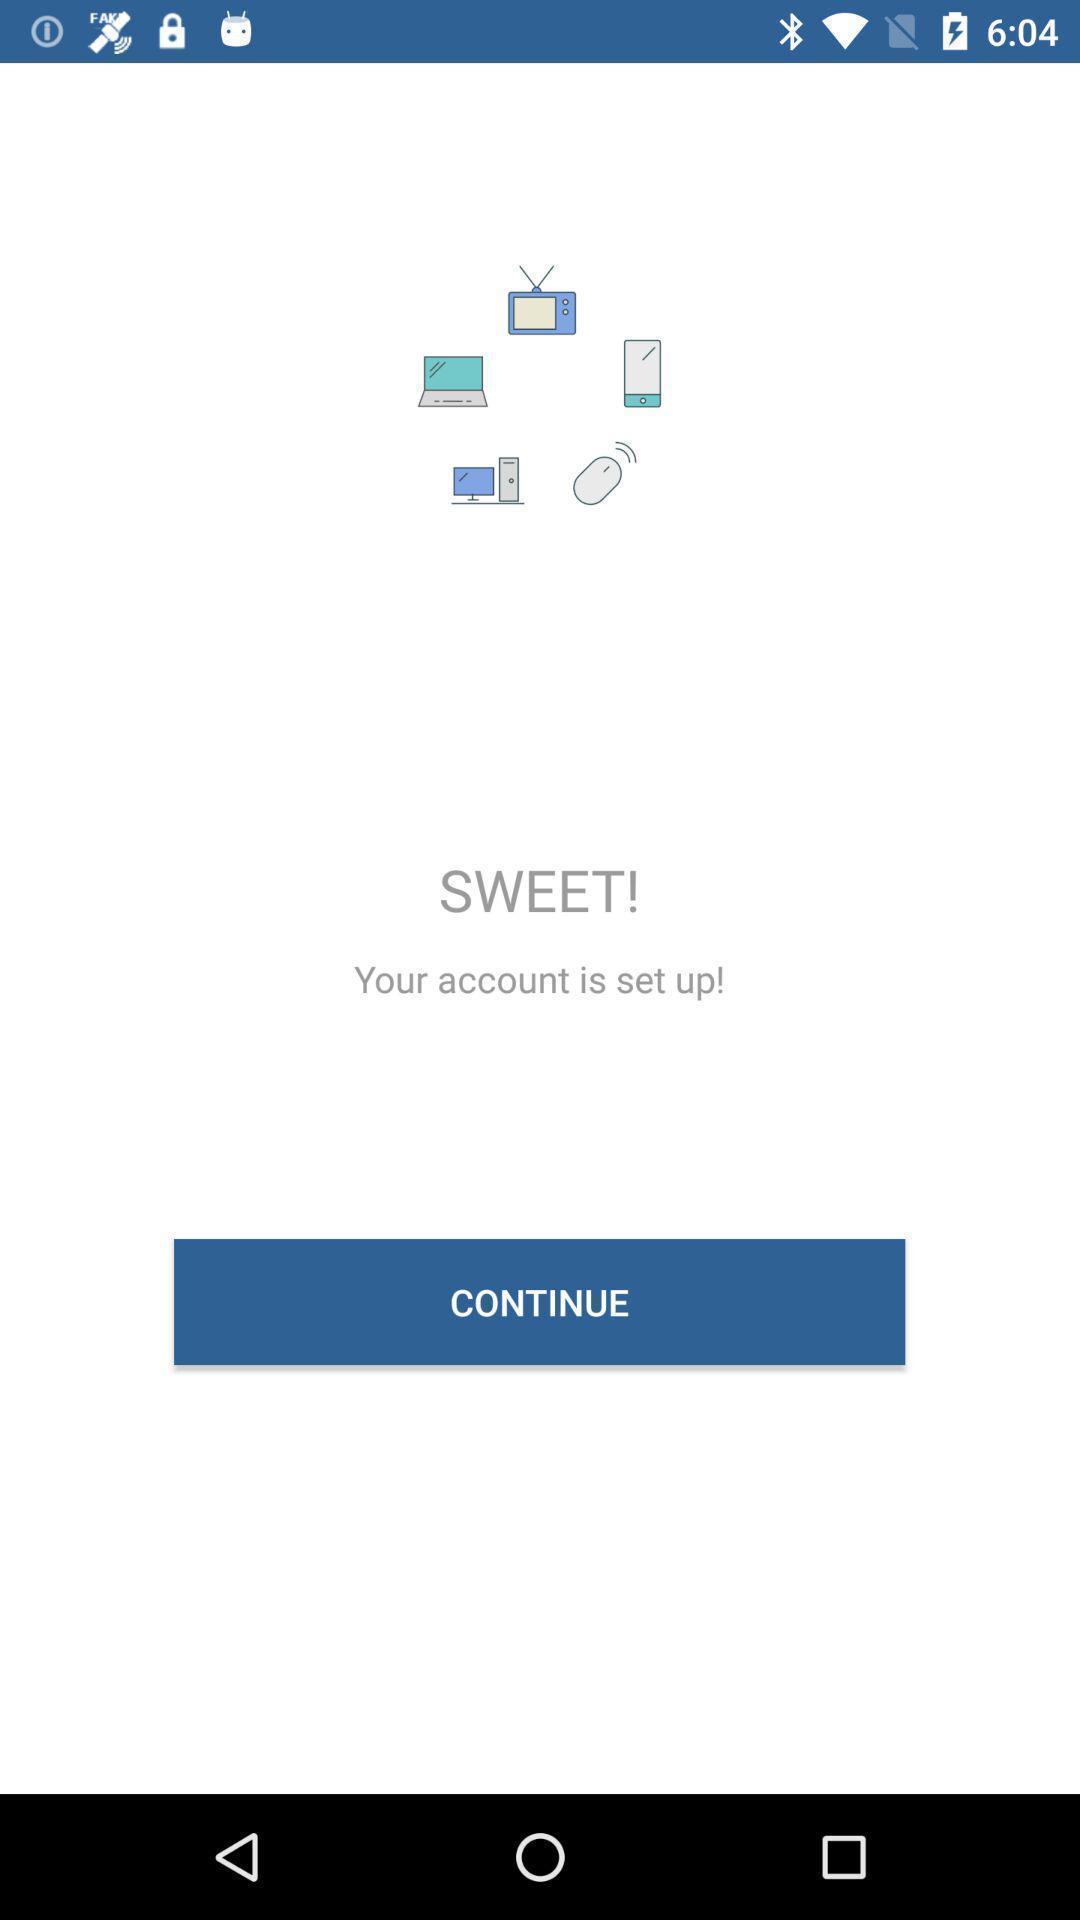Describe this image in words. Page requesting to continue on an app. 